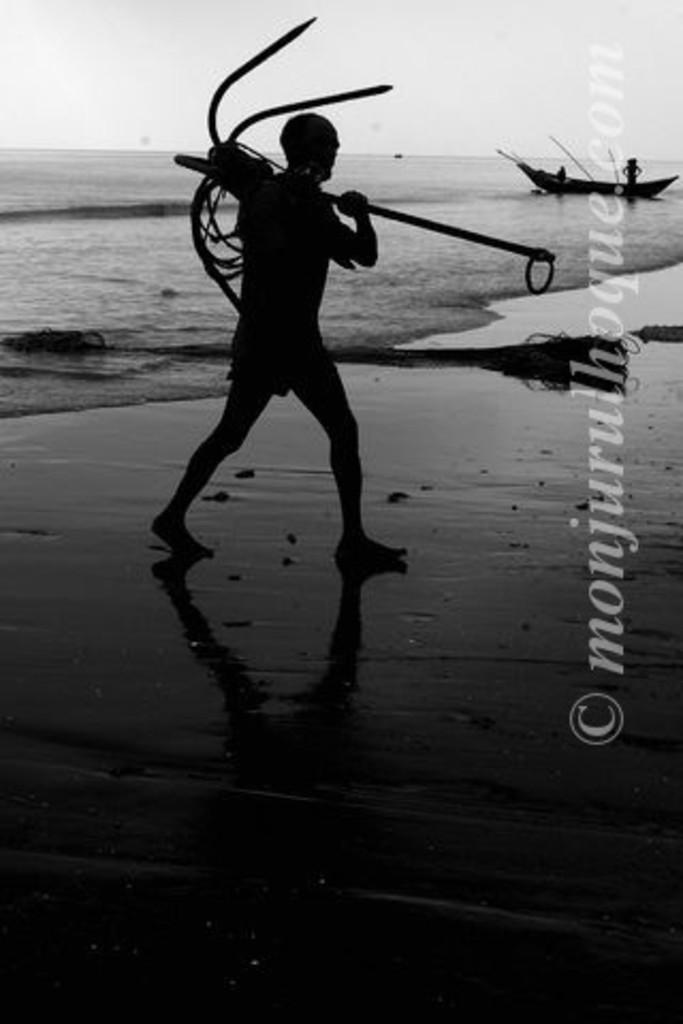What is the watermakr?
Provide a short and direct response. Monjurulhoque.com. 